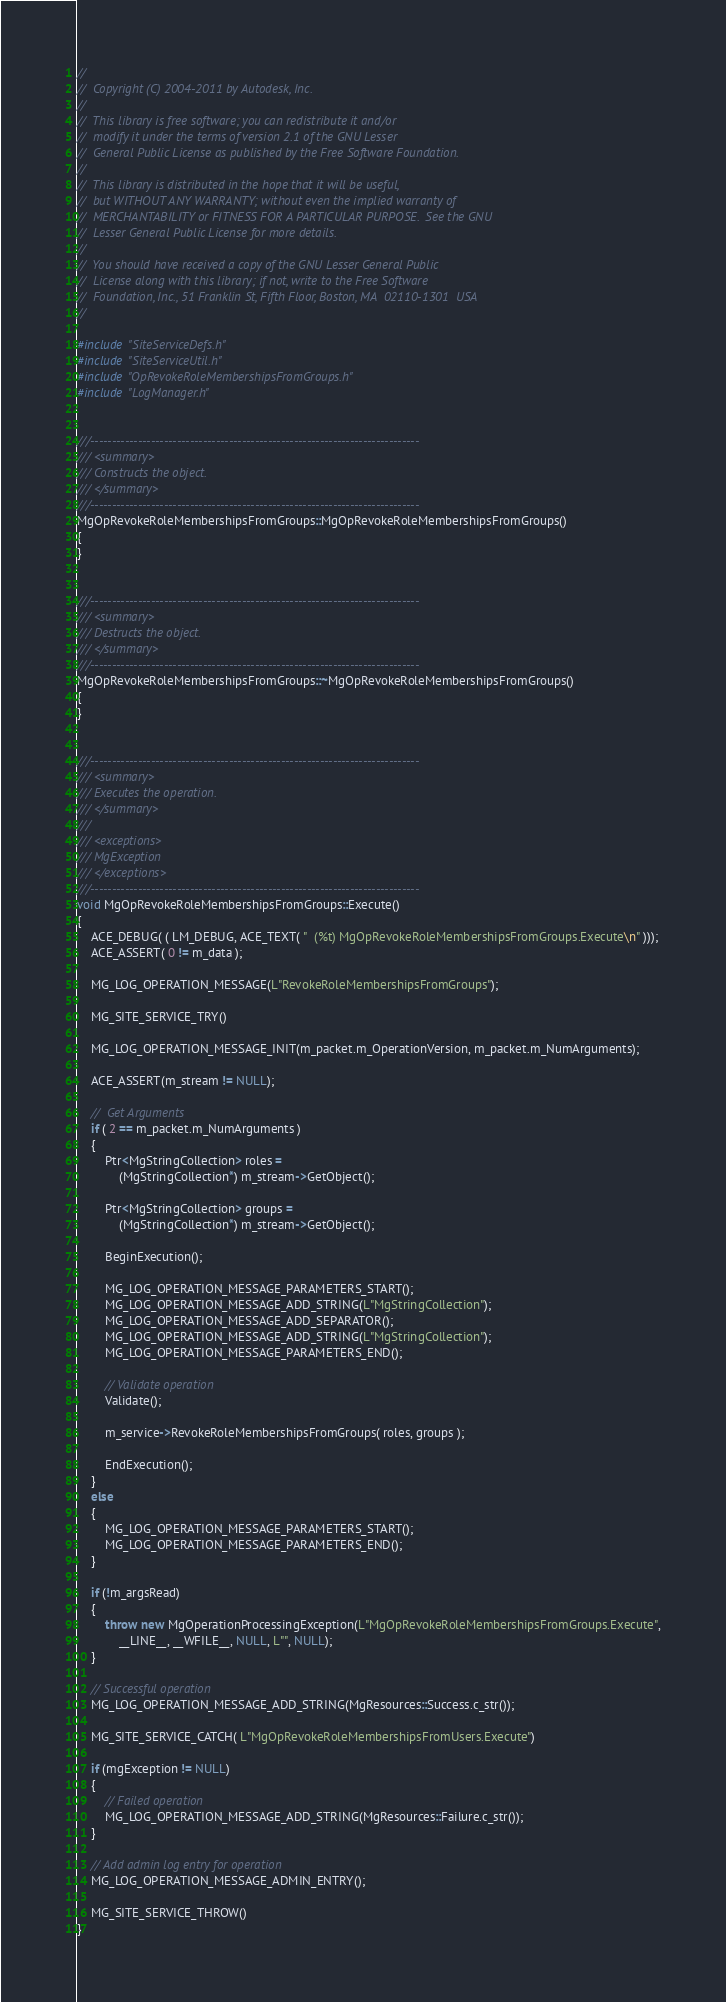<code> <loc_0><loc_0><loc_500><loc_500><_C++_>//
//  Copyright (C) 2004-2011 by Autodesk, Inc.
//
//  This library is free software; you can redistribute it and/or
//  modify it under the terms of version 2.1 of the GNU Lesser
//  General Public License as published by the Free Software Foundation.
//
//  This library is distributed in the hope that it will be useful,
//  but WITHOUT ANY WARRANTY; without even the implied warranty of
//  MERCHANTABILITY or FITNESS FOR A PARTICULAR PURPOSE.  See the GNU
//  Lesser General Public License for more details.
//
//  You should have received a copy of the GNU Lesser General Public
//  License along with this library; if not, write to the Free Software
//  Foundation, Inc., 51 Franklin St, Fifth Floor, Boston, MA  02110-1301  USA
//

#include "SiteServiceDefs.h"
#include "SiteServiceUtil.h"
#include "OpRevokeRoleMembershipsFromGroups.h"
#include "LogManager.h"


///----------------------------------------------------------------------------
/// <summary>
/// Constructs the object.
/// </summary>
///----------------------------------------------------------------------------
MgOpRevokeRoleMembershipsFromGroups::MgOpRevokeRoleMembershipsFromGroups()
{
}


///----------------------------------------------------------------------------
/// <summary>
/// Destructs the object.
/// </summary>
///----------------------------------------------------------------------------
MgOpRevokeRoleMembershipsFromGroups::~MgOpRevokeRoleMembershipsFromGroups()
{
}


///----------------------------------------------------------------------------
/// <summary>
/// Executes the operation.
/// </summary>
///
/// <exceptions>
/// MgException
/// </exceptions>
///----------------------------------------------------------------------------
void MgOpRevokeRoleMembershipsFromGroups::Execute()
{
    ACE_DEBUG( ( LM_DEBUG, ACE_TEXT( "  (%t) MgOpRevokeRoleMembershipsFromGroups.Execute\n" )));
    ACE_ASSERT( 0 != m_data );

    MG_LOG_OPERATION_MESSAGE(L"RevokeRoleMembershipsFromGroups");

    MG_SITE_SERVICE_TRY()

    MG_LOG_OPERATION_MESSAGE_INIT(m_packet.m_OperationVersion, m_packet.m_NumArguments);

    ACE_ASSERT(m_stream != NULL);

    //  Get Arguments
    if ( 2 == m_packet.m_NumArguments )
    {
        Ptr<MgStringCollection> roles =
            (MgStringCollection*) m_stream->GetObject();

        Ptr<MgStringCollection> groups =
            (MgStringCollection*) m_stream->GetObject();

        BeginExecution();

        MG_LOG_OPERATION_MESSAGE_PARAMETERS_START();
        MG_LOG_OPERATION_MESSAGE_ADD_STRING(L"MgStringCollection");
        MG_LOG_OPERATION_MESSAGE_ADD_SEPARATOR();
        MG_LOG_OPERATION_MESSAGE_ADD_STRING(L"MgStringCollection");
        MG_LOG_OPERATION_MESSAGE_PARAMETERS_END();

        // Validate operation
        Validate();

        m_service->RevokeRoleMembershipsFromGroups( roles, groups );

        EndExecution();
    }
    else
    {
        MG_LOG_OPERATION_MESSAGE_PARAMETERS_START();
        MG_LOG_OPERATION_MESSAGE_PARAMETERS_END();
    }

    if (!m_argsRead)
    {
        throw new MgOperationProcessingException(L"MgOpRevokeRoleMembershipsFromGroups.Execute",
            __LINE__, __WFILE__, NULL, L"", NULL);
    }

    // Successful operation
    MG_LOG_OPERATION_MESSAGE_ADD_STRING(MgResources::Success.c_str());

    MG_SITE_SERVICE_CATCH( L"MgOpRevokeRoleMembershipsFromUsers.Execute")

    if (mgException != NULL)
    {
        // Failed operation
        MG_LOG_OPERATION_MESSAGE_ADD_STRING(MgResources::Failure.c_str());
    }

    // Add admin log entry for operation
    MG_LOG_OPERATION_MESSAGE_ADMIN_ENTRY();

    MG_SITE_SERVICE_THROW()
}
</code> 